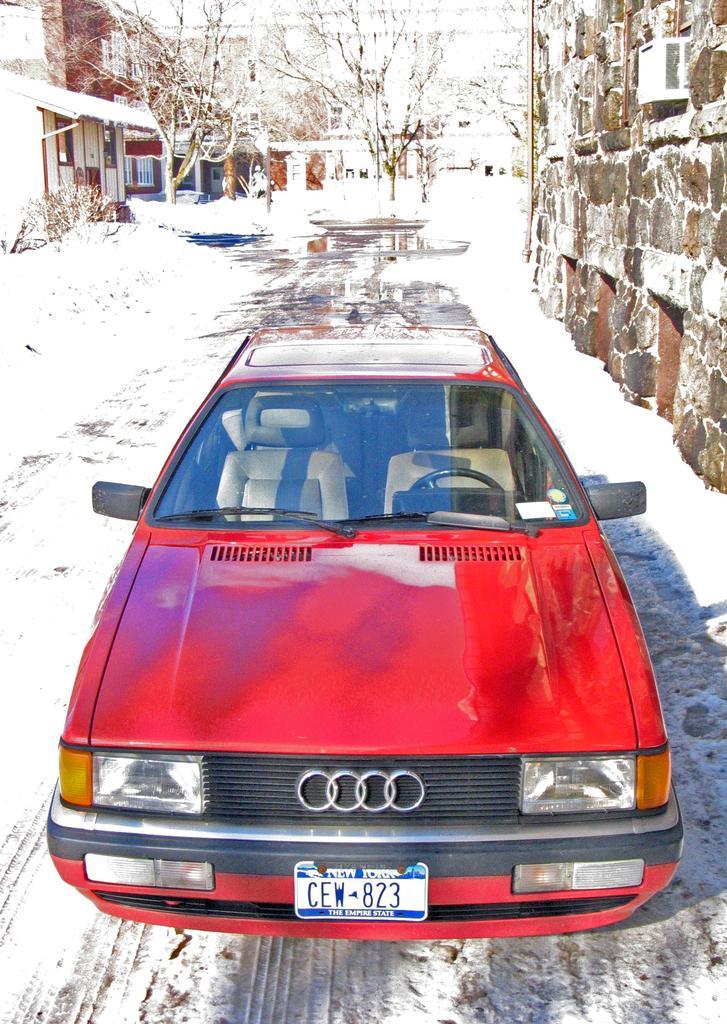Please provide a concise description of this image. In the center of the image we can see a car which is in red color. In the background there are buildings and trees. We can see snow. On the right there is a wall. 